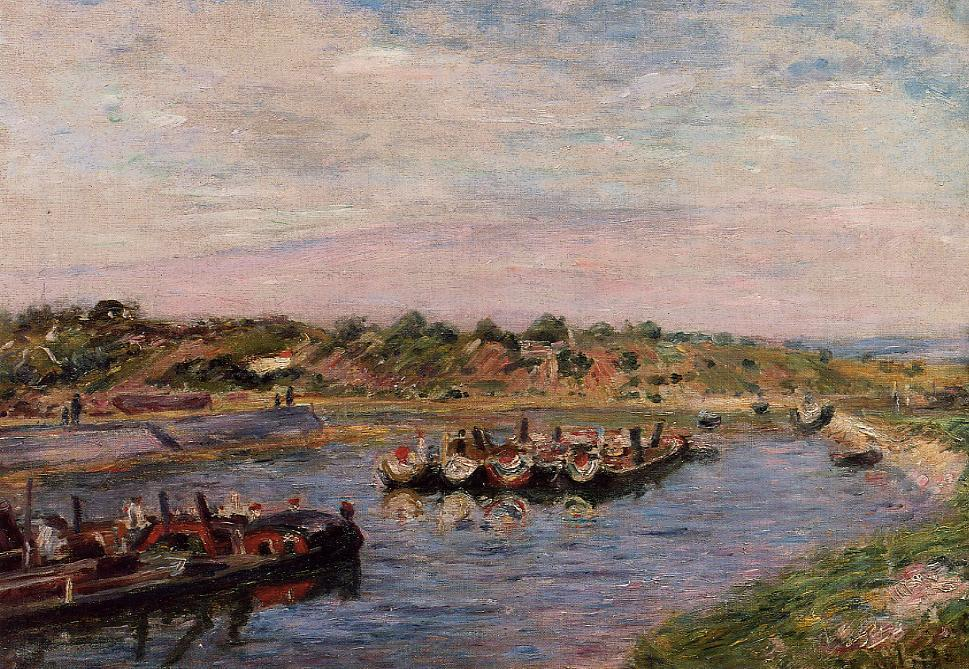Can you elaborate on the elements of the picture provided? The painting you're referring to beautifully encapsulates the principles of impressionism through its vivid depiction of a river crowded with rowboats and bustling activity. The technique used is characteristic of impressionism, with quick and vibrant brushstrokes that blend together to form a lively yet somewhat hazy scene, typical of capturing fleeting moments. The atmosphere is rendered through soft pastel hues—pinks, blues, and greens blend seamlessly, evoking a serene yet active river scene. The boats, adorned with flags, and the well-dressed people on the riverbank suggest a festive occasion, perhaps a local regatta or market day. The background features an undulating hill with sparse trees and houses, lending depth and context to the waterside activities. Additionally, small details like the reflections in the water and the light pink tones in the sky enhance the overall sense of time and place, typical of a late afternoon in spring. This scene is not just a visual experience; it is an invitation to contemplate the transient beauty of everyday moments. 